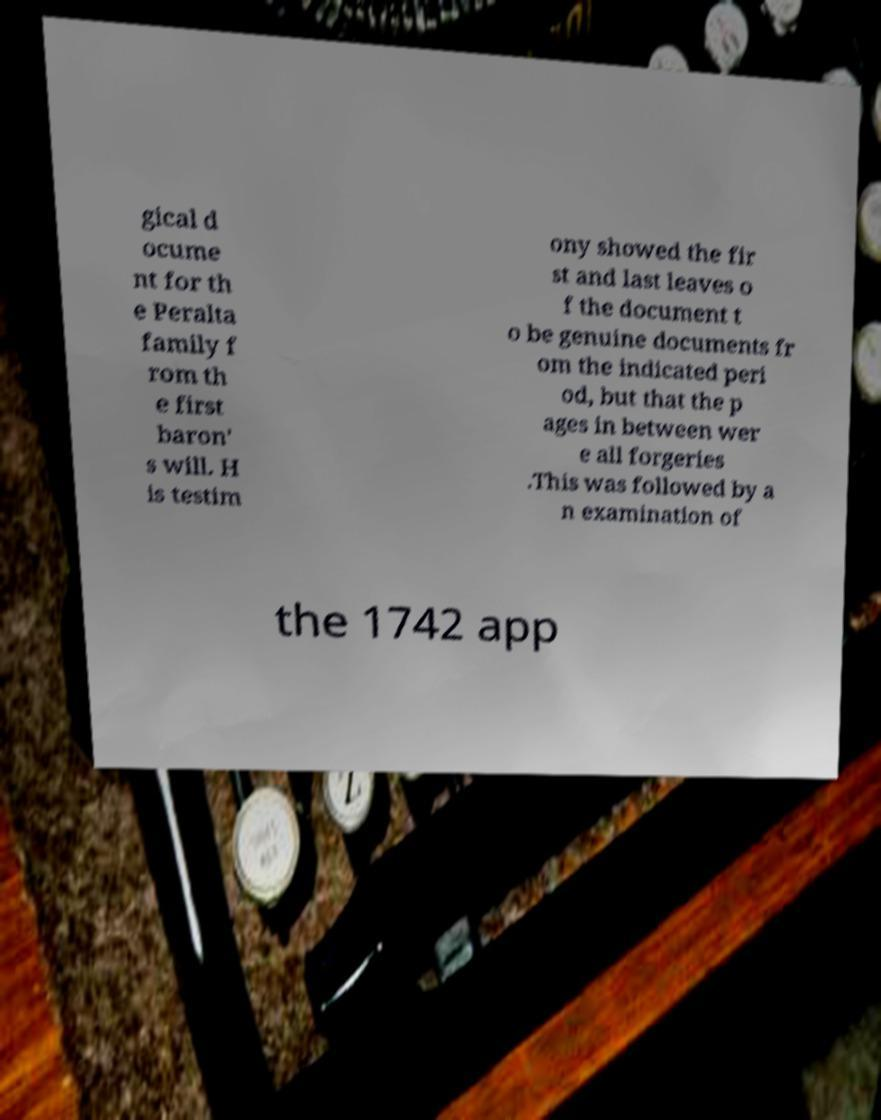Could you extract and type out the text from this image? gical d ocume nt for th e Peralta family f rom th e first baron' s will. H is testim ony showed the fir st and last leaves o f the document t o be genuine documents fr om the indicated peri od, but that the p ages in between wer e all forgeries .This was followed by a n examination of the 1742 app 